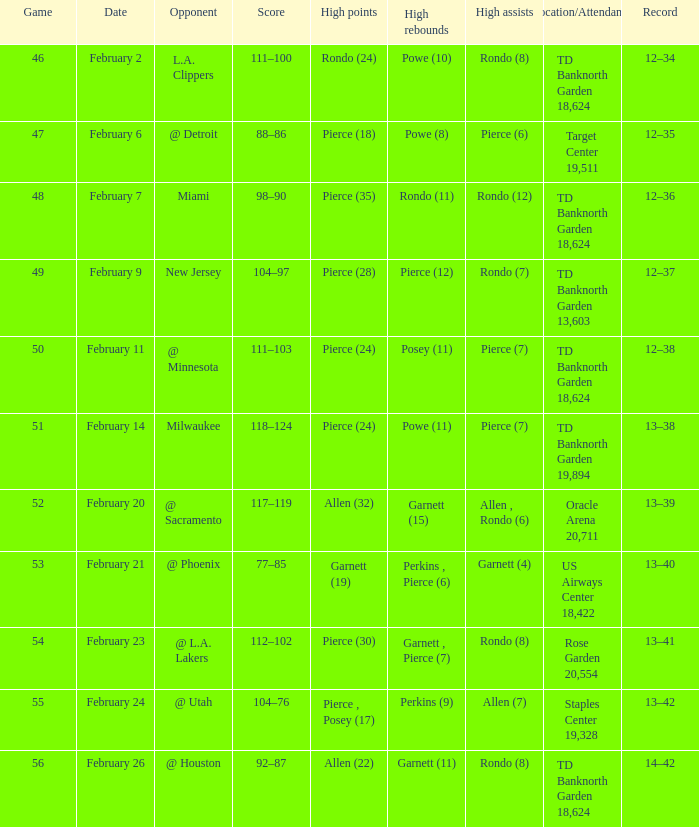How many games with significant rebounds took place on february 26? 1.0. 